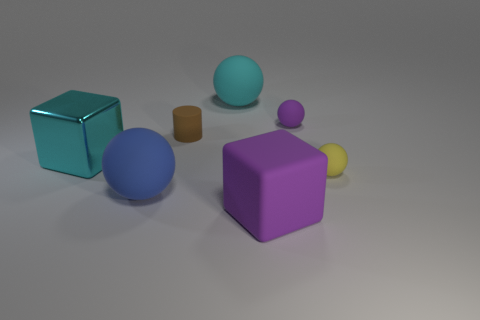Subtract all large blue rubber spheres. How many spheres are left? 3 Add 3 tiny purple objects. How many objects exist? 10 Subtract all purple spheres. How many spheres are left? 3 Subtract all spheres. How many objects are left? 3 Subtract 1 cubes. How many cubes are left? 1 Add 5 purple spheres. How many purple spheres exist? 6 Subtract 0 gray cubes. How many objects are left? 7 Subtract all blue cylinders. Subtract all blue cubes. How many cylinders are left? 1 Subtract all blue balls. How many gray cylinders are left? 0 Subtract all rubber balls. Subtract all tiny rubber things. How many objects are left? 0 